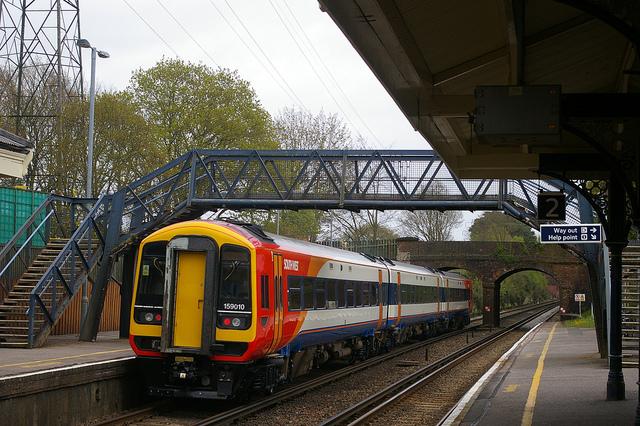Where is the number 2?
Concise answer only. On train. What tie of vehicle is this?
Be succinct. Train. What is the train traveling under?
Write a very short answer. Bridge. 